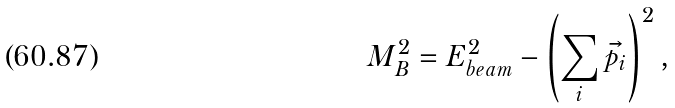<formula> <loc_0><loc_0><loc_500><loc_500>M _ { B } ^ { 2 } = E _ { b e a m } ^ { 2 } - \left ( \sum _ { i } { \vec { p _ { i } } } \right ) ^ { 2 } ,</formula> 